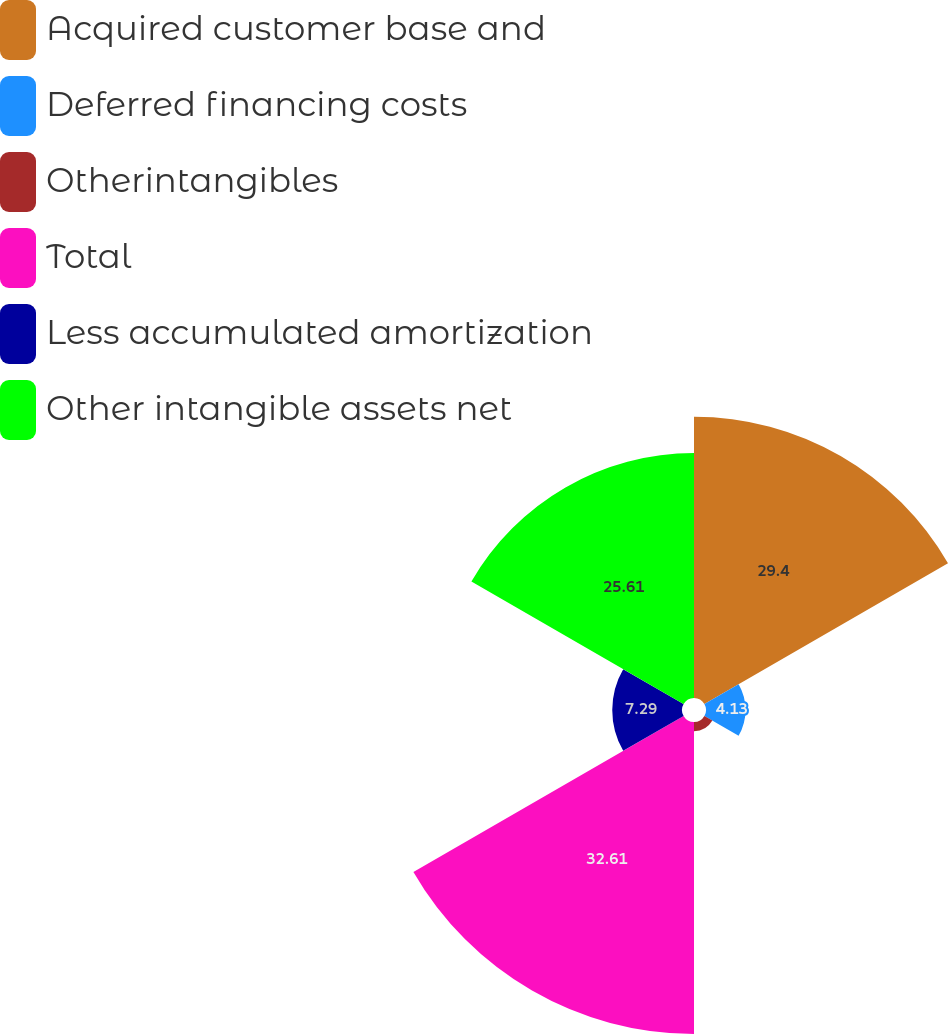Convert chart to OTSL. <chart><loc_0><loc_0><loc_500><loc_500><pie_chart><fcel>Acquired customer base and<fcel>Deferred financing costs<fcel>Otherintangibles<fcel>Total<fcel>Less accumulated amortization<fcel>Other intangible assets net<nl><fcel>29.4%<fcel>4.13%<fcel>0.96%<fcel>32.61%<fcel>7.29%<fcel>25.61%<nl></chart> 